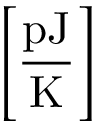Convert formula to latex. <formula><loc_0><loc_0><loc_500><loc_500>\left [ \frac { p J } { K } \right ]</formula> 